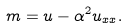<formula> <loc_0><loc_0><loc_500><loc_500>m = u - \alpha ^ { 2 } u _ { x x } .</formula> 